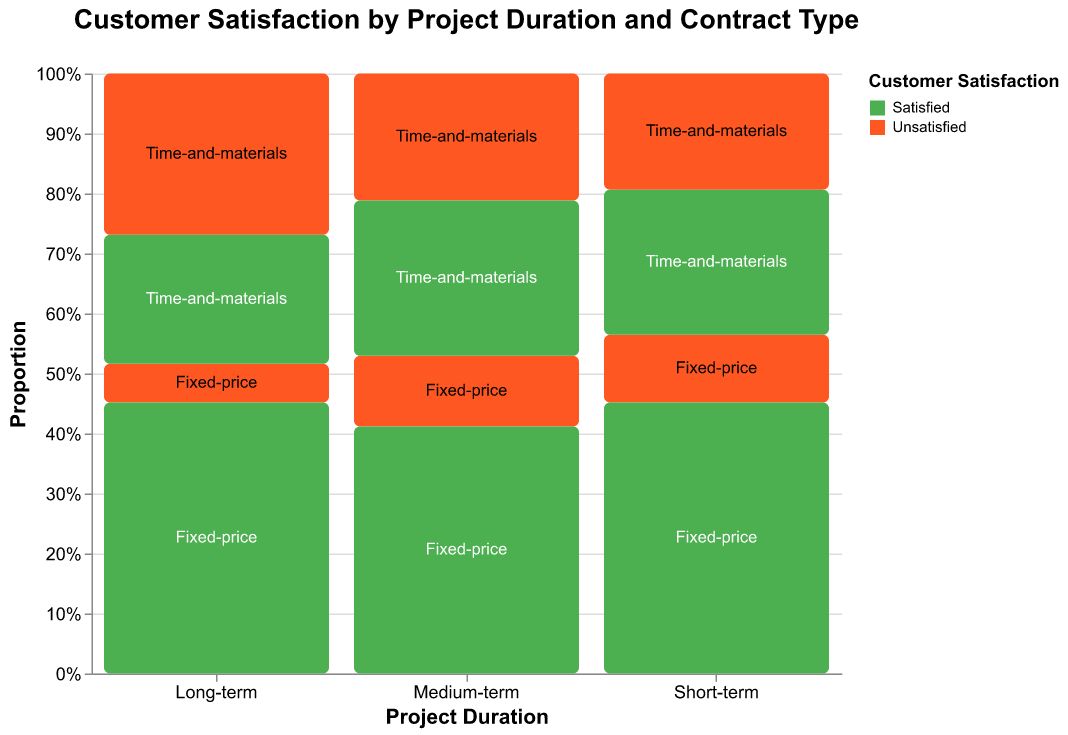What's the title of the plot? The title of the plot is located at the top center and is typically rendered in a larger and bold font.
Answer: Customer Satisfaction by Project Duration and Contract Type How is customer satisfaction distributed for short-term projects with fixed-price contracts? To answer, look for the bar corresponding to 'Short-term' and 'Fixed-price'. The 'Satisfied' part is green, while the 'Unsatisfied' part is orange, and their relative sizes give the distribution.
Answer: 28 Satisfied, 7 Unsatisfied Which project duration has the highest number of satisfied customers for fixed-price contracts? Check the green sections for each fixed-price category under 'Short-term', 'Medium-term', and 'Long-term'. The longest green bar indicates the highest number.
Answer: Long-term Are there more satisfied or unsatisfied customers in long-term projects with time-and-materials contracts? Look at the 'Long-term' column under 'Time-and-materials'. Compare the size of the green (Satisfied) section to the orange (Unsatisfied) section to see which is larger.
Answer: Unsatisfied What is the proportion of satisfied customers in medium-term projects with time-and-materials contracts? Find the 'Medium-term' column and look at the 'Time-and-materials' section. The proportion is the size of the green part divided by the total height of the 'Medium-term' stack. Calculate 22/(22+18).
Answer: 55% How does customer satisfaction vary between fixed-price and time-and-materials contracts in short-term projects? Compare the green and orange parts of the 'Short-term' section for both 'Fixed-price' and 'Time-and-materials' contracts.
Answer: Fixed-price has more satisfied customers Which contract type shows a more significant proportion of satisfied customers across all project durations? Sum up the satisfied and unsatisfied counts for both contract types across all durations and compare their proportions.
Answer: Fixed-price In which project duration do time-and-materials contracts have the highest dissatisfaction rate? Analyze the 'Unsatisfied' sections in 'Short-term', 'Medium-term', and 'Long-term' under 'Time-and-materials'. The one with the largest orange bar indicates the highest rate.
Answer: Long-term Which project duration has the overall lowest number of unsatisfied customers? Compare the total orange sections of 'Short-term', 'Medium-term', and 'Long-term'. The smallest one is the duration with the lowest number of unsatisfied customers.
Answer: Long-term What's the difference in the number of satisfied customers between short-term and long-term fixed-price projects? Subtract the number of satisfied customers in short-term fixed-price from long-term fixed-price (42 - 28).
Answer: 14 